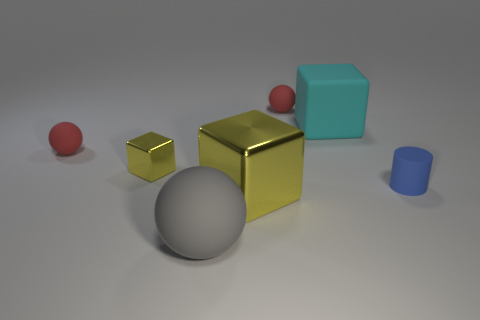Add 1 blue things. How many objects exist? 8 Subtract all large blocks. How many blocks are left? 1 Subtract all blocks. How many objects are left? 4 Add 4 tiny yellow things. How many tiny yellow things exist? 5 Subtract 0 brown cylinders. How many objects are left? 7 Subtract all gray rubber things. Subtract all large cyan objects. How many objects are left? 5 Add 3 red things. How many red things are left? 5 